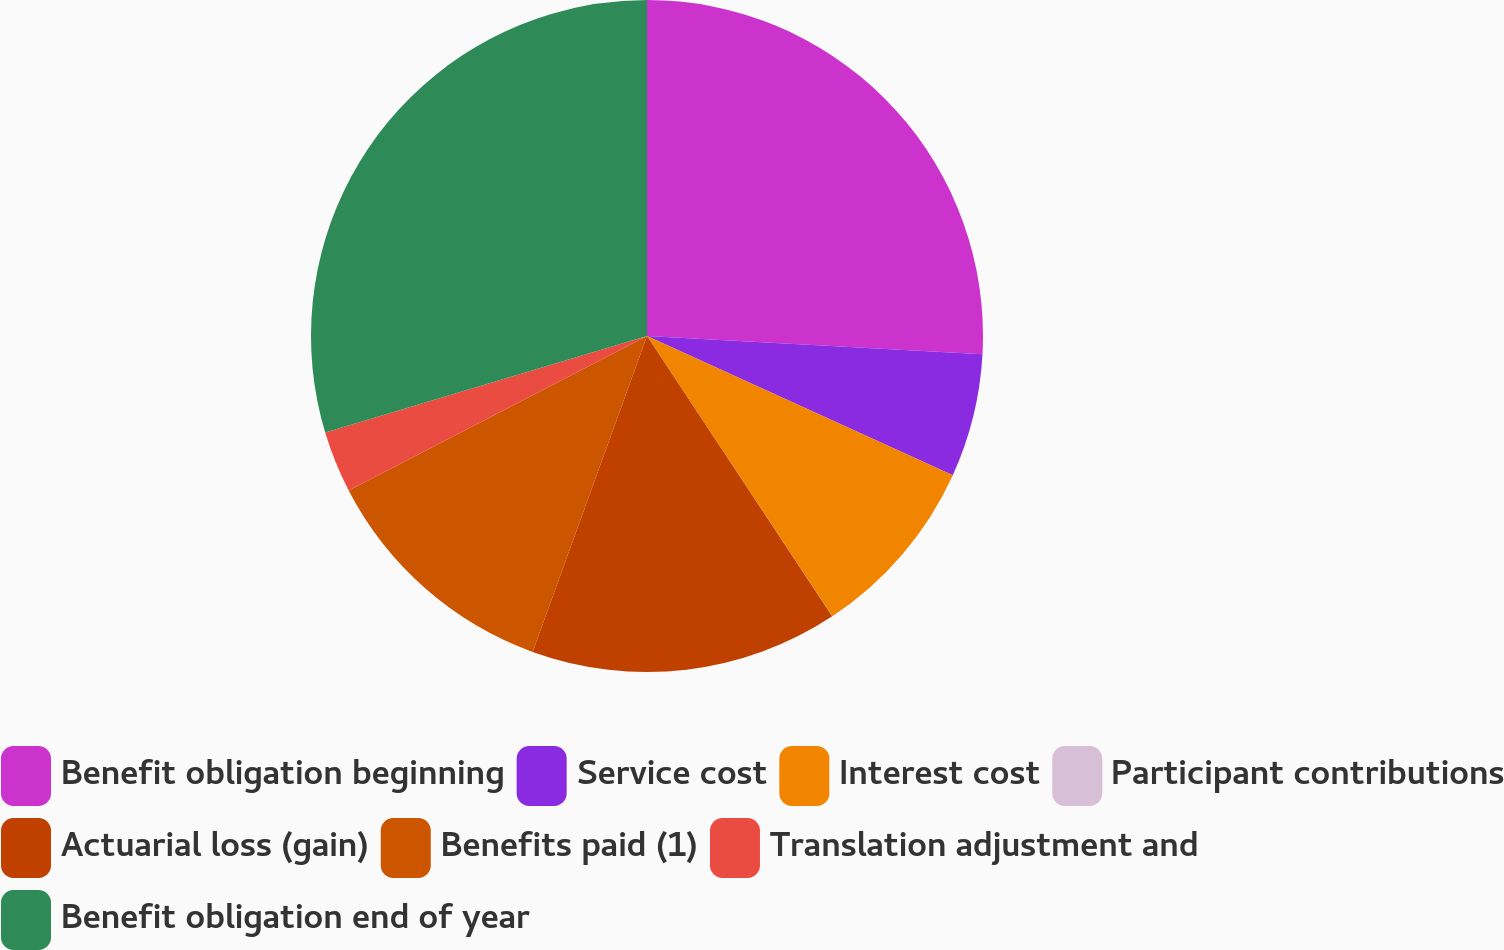Convert chart to OTSL. <chart><loc_0><loc_0><loc_500><loc_500><pie_chart><fcel>Benefit obligation beginning<fcel>Service cost<fcel>Interest cost<fcel>Participant contributions<fcel>Actuarial loss (gain)<fcel>Benefits paid (1)<fcel>Translation adjustment and<fcel>Benefit obligation end of year<nl><fcel>25.87%<fcel>5.93%<fcel>8.9%<fcel>0.01%<fcel>14.82%<fcel>11.86%<fcel>2.97%<fcel>29.64%<nl></chart> 